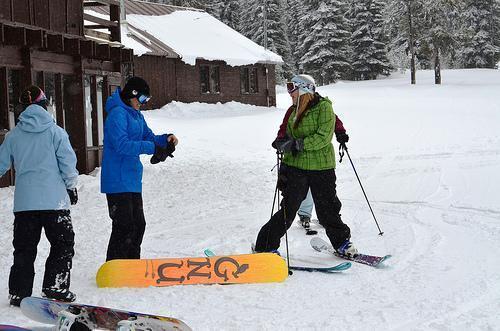How many women are there?
Give a very brief answer. 1. 